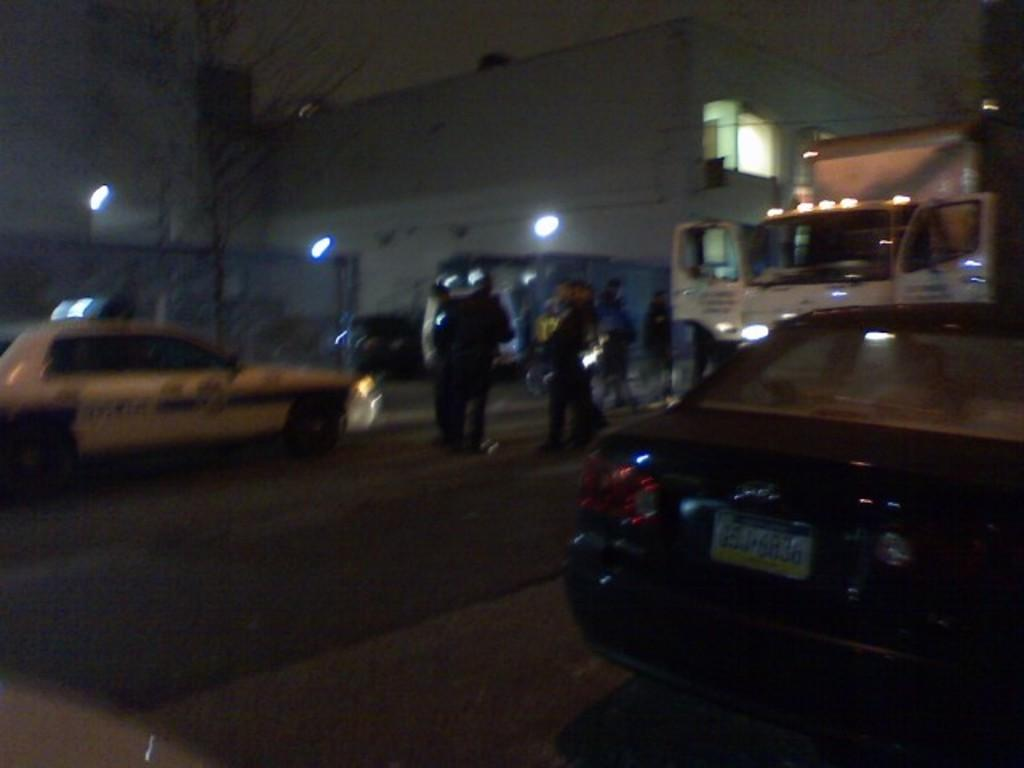What can be seen on the road in the image? There are vehicles on the road in the image. Are there any living beings visible in the image? Yes, there are people visible in the image. What type of illumination is present in the image? There are lights present in the image. What type of natural elements can be seen in the image? Trees are visible in the image. What type of man-made structures can be seen in the image? There are buildings in the image. What is visible in the background of the image? The sky is visible in the background of the image. Where is the throne located in the image? There is no throne present in the image. What type of birds can be seen flying in the image? There are no birds visible in the image. Can you describe the romantic interaction between the people in the image? There is no romantic interaction or kiss depicted in the image. 